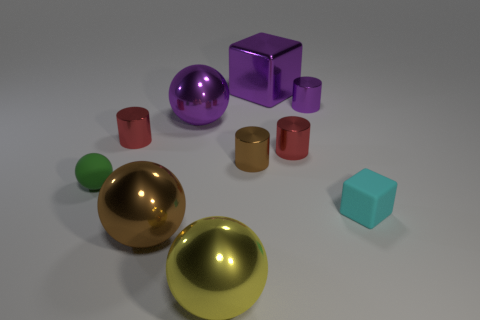Is there any other thing that has the same material as the purple cylinder?
Ensure brevity in your answer.  Yes. The matte object that is on the left side of the red metal object that is right of the purple ball is what color?
Give a very brief answer. Green. How many objects are both right of the big metal cube and in front of the brown ball?
Your response must be concise. 0. Are there fewer small green balls in front of the large yellow metallic object than tiny matte things that are to the right of the large purple metallic ball?
Keep it short and to the point. Yes. Does the tiny cyan matte thing have the same shape as the yellow metal thing?
Keep it short and to the point. No. How many other things are there of the same size as the cyan cube?
Keep it short and to the point. 5. What number of things are matte blocks that are on the right side of the tiny green matte ball or large metallic things behind the big yellow thing?
Ensure brevity in your answer.  4. What number of large purple metallic things are the same shape as the cyan matte thing?
Make the answer very short. 1. The big thing that is behind the big yellow thing and in front of the tiny cyan cube is made of what material?
Provide a succinct answer. Metal. Is the size of the brown cylinder the same as the green sphere?
Provide a succinct answer. Yes. 